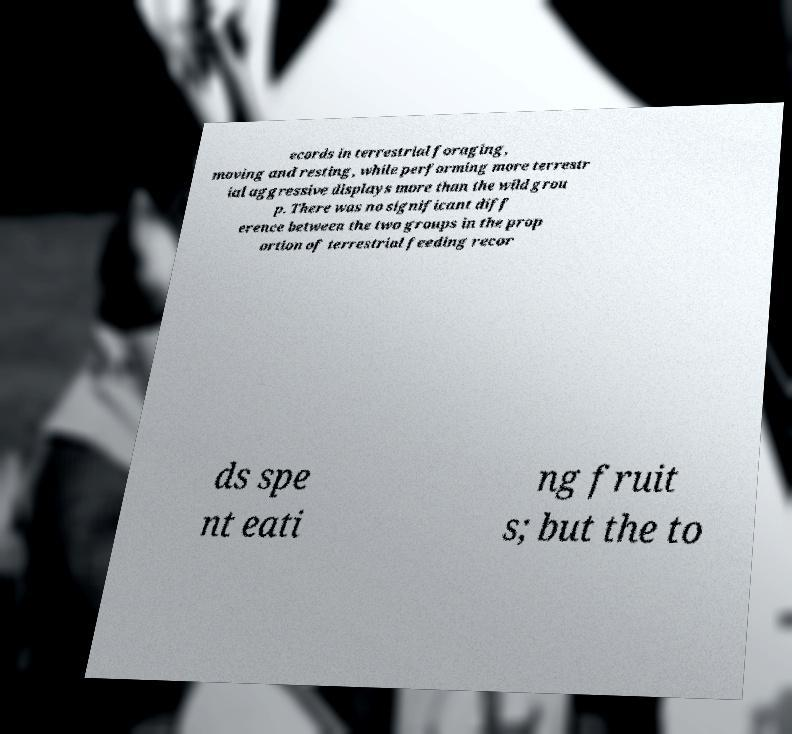Can you accurately transcribe the text from the provided image for me? ecords in terrestrial foraging, moving and resting, while performing more terrestr ial aggressive displays more than the wild grou p. There was no significant diff erence between the two groups in the prop ortion of terrestrial feeding recor ds spe nt eati ng fruit s; but the to 